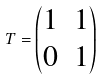Convert formula to latex. <formula><loc_0><loc_0><loc_500><loc_500>T = \begin{pmatrix} 1 & 1 \\ 0 & 1 \end{pmatrix}</formula> 